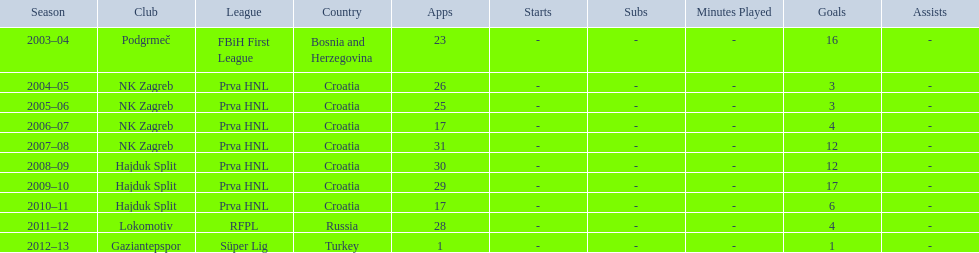After scoring against bulgaria in zenica, ibricic also scored against this team in a 7-0 victory in zenica less then a month after the friendly match against bulgaria. Estonia. 